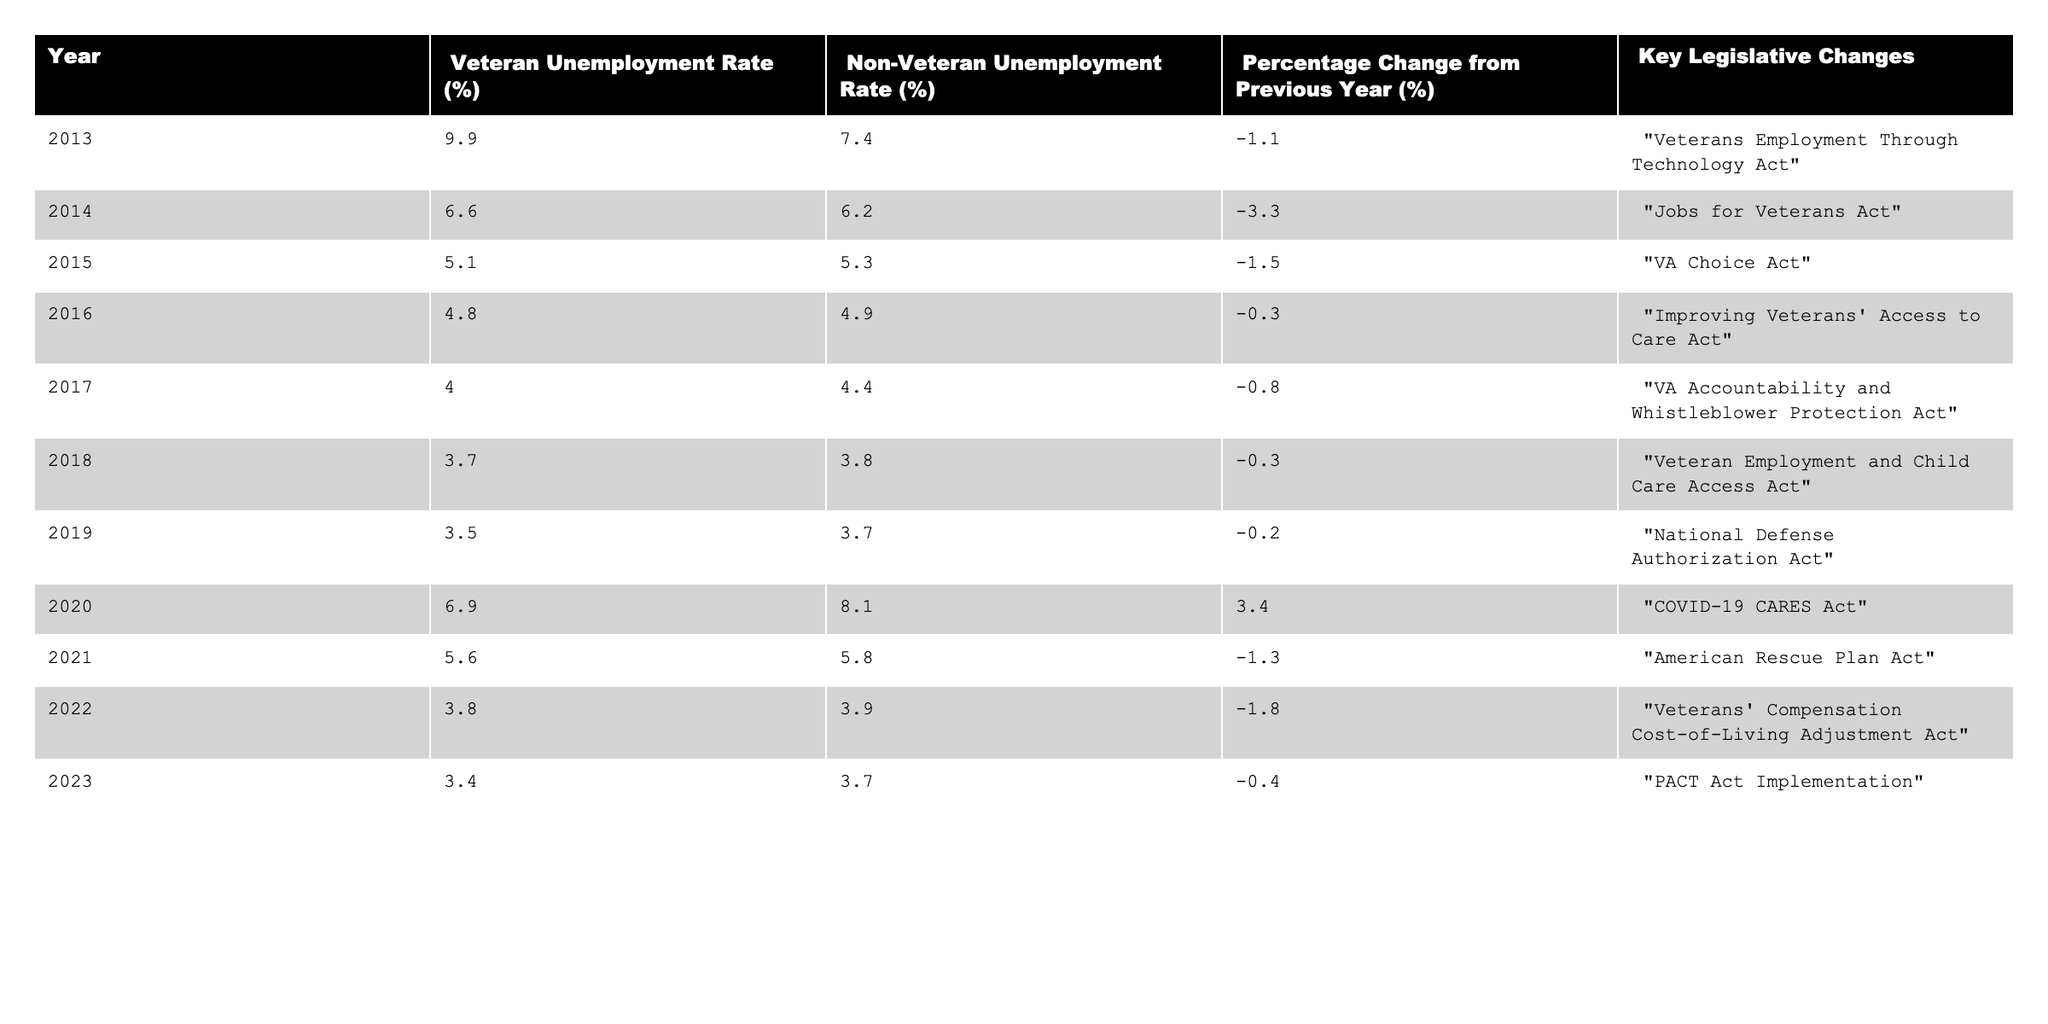What was the veteran unemployment rate in 2013? The table shows that the veteran unemployment rate for the year 2013 is listed as 9.9%.
Answer: 9.9% What legislative change occurred in 2018? According to the table, the legislative change in 2018 was the "Veteran Employment and Child Care Access Act."
Answer: Veteran Employment and Child Care Access Act What was the percentage change in veteran unemployment from 2019 to 2020? To find the percentage change, subtract the 2019 rate (3.5%) from the 2020 rate (6.9%), which gives 3.4%. The percentage change is positive, indicating an increase.
Answer: 3.4% What is the average non-veteran unemployment rate over the last decade? The non-veteran unemployment rates from 2013 to 2023 are: 7.4%, 6.2%, 5.3%, 4.9%, 4.4%, 3.8%, 3.7%, 8.1%, 5.8%, 3.9%, 3.7%. Adding these values gives 57.6%, and dividing by 11 yields an average of approximately 5.24%.
Answer: 5.24% Did the veteran unemployment rate decrease in 2014 compared to 2013? The table indicates that the veteran unemployment rate was 9.9% in 2013 and decreased to 6.6% in 2014. Thus, it did decrease.
Answer: Yes Which year had the lowest veteran unemployment rate? By examining the table, the lowest veteran unemployment rate is found in 2023, which is 3.4%.
Answer: 2023 What was the trend in veteran unemployment rates from 2013 to 2019? Reviewing the table, the veteran unemployment rates decreased from 9.9% in 2013 to 3.5% in 2019, indicating a consistent downward trend over that period.
Answer: Decreasing trend How much did the veteran unemployment rate increase from 2019 to 2020? The veteran unemployment rate was 3.5% in 2019 and rose to 6.9% in 2020. Subtracting 3.5% from 6.9% yields an increase of 3.4%.
Answer: 3.4% Was the percentage change in veteran unemployment positive in 2020? The percentage change from 2019 to 2020 was 3.4%, which is positive, indicating an increase in unemployment.
Answer: Yes What was the difference in unemployment rates between veterans and non-veterans in 2021? In the year 2021, the veteran unemployment rate was 5.6% and the non-veteran rate was 5.8%. The difference is calculated as 5.8% - 5.6% = 0.2%.
Answer: 0.2% 